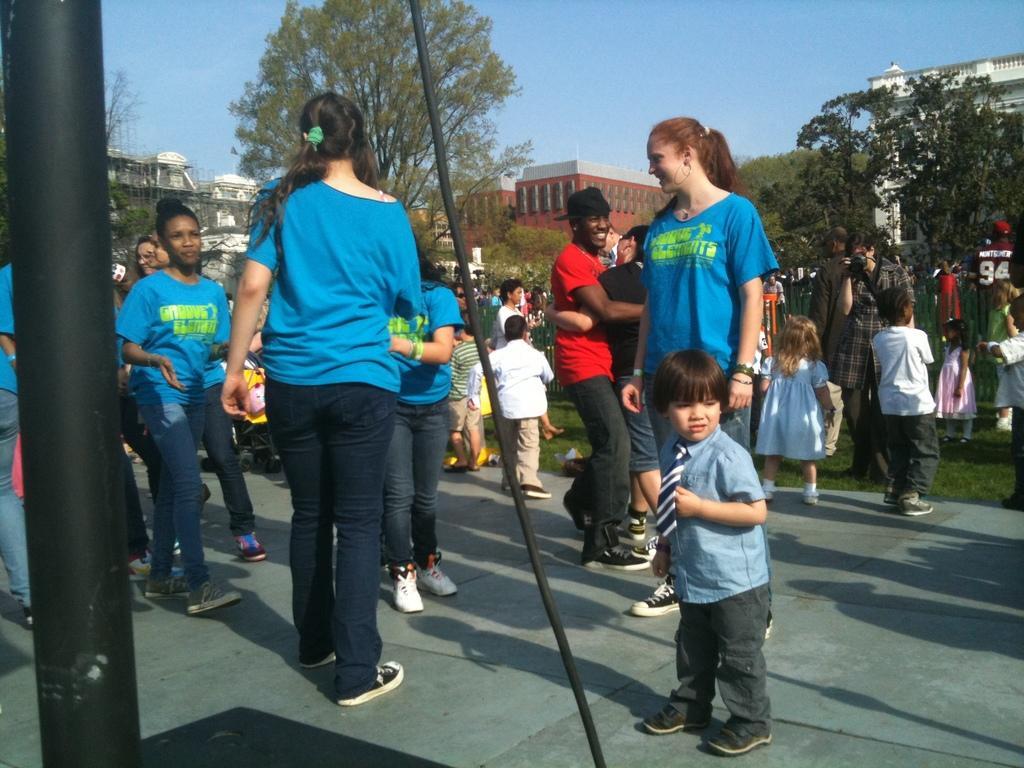Could you give a brief overview of what you see in this image? In this image there are a group of people standing, and there are some children. At the bottom there is walkway and grass, and in the foreground there is pole and wire and in the background there are some buildings and trees. At the top there is sky. 